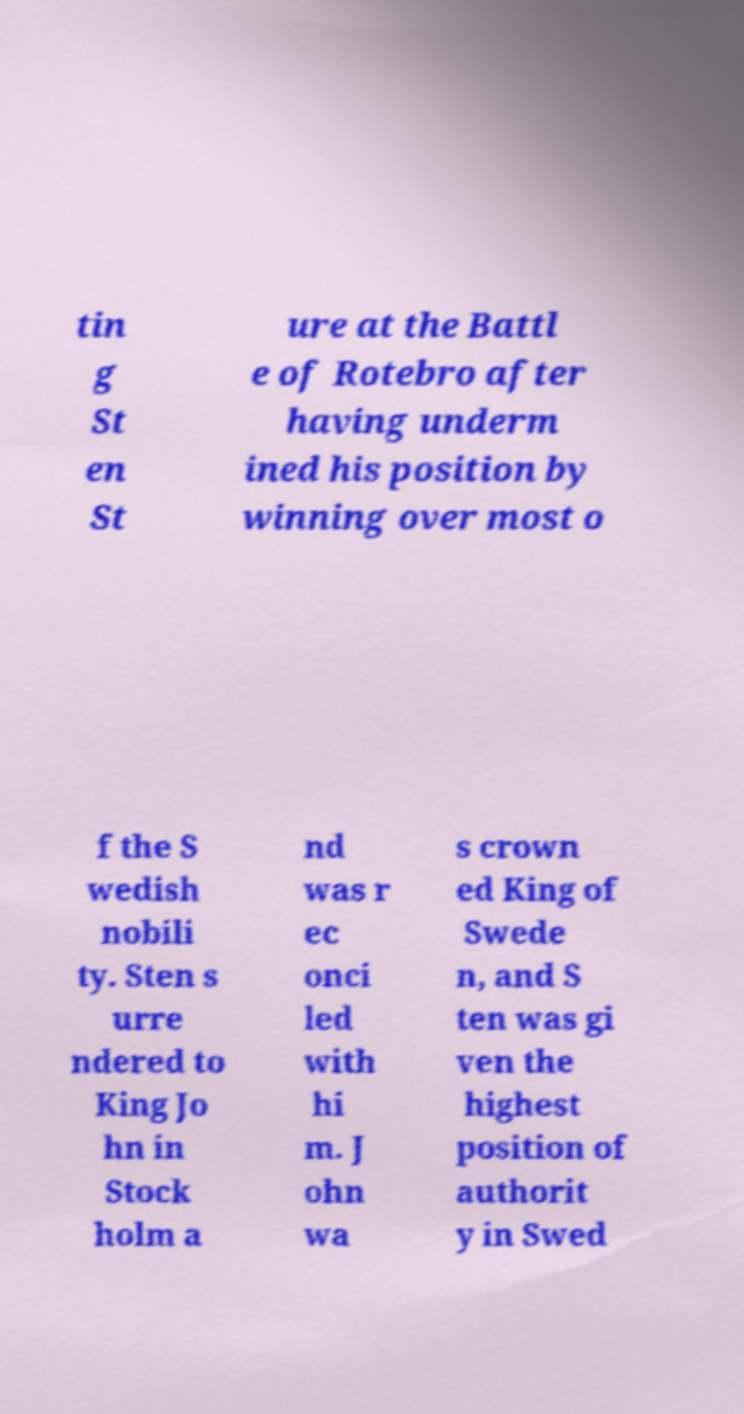Could you assist in decoding the text presented in this image and type it out clearly? tin g St en St ure at the Battl e of Rotebro after having underm ined his position by winning over most o f the S wedish nobili ty. Sten s urre ndered to King Jo hn in Stock holm a nd was r ec onci led with hi m. J ohn wa s crown ed King of Swede n, and S ten was gi ven the highest position of authorit y in Swed 